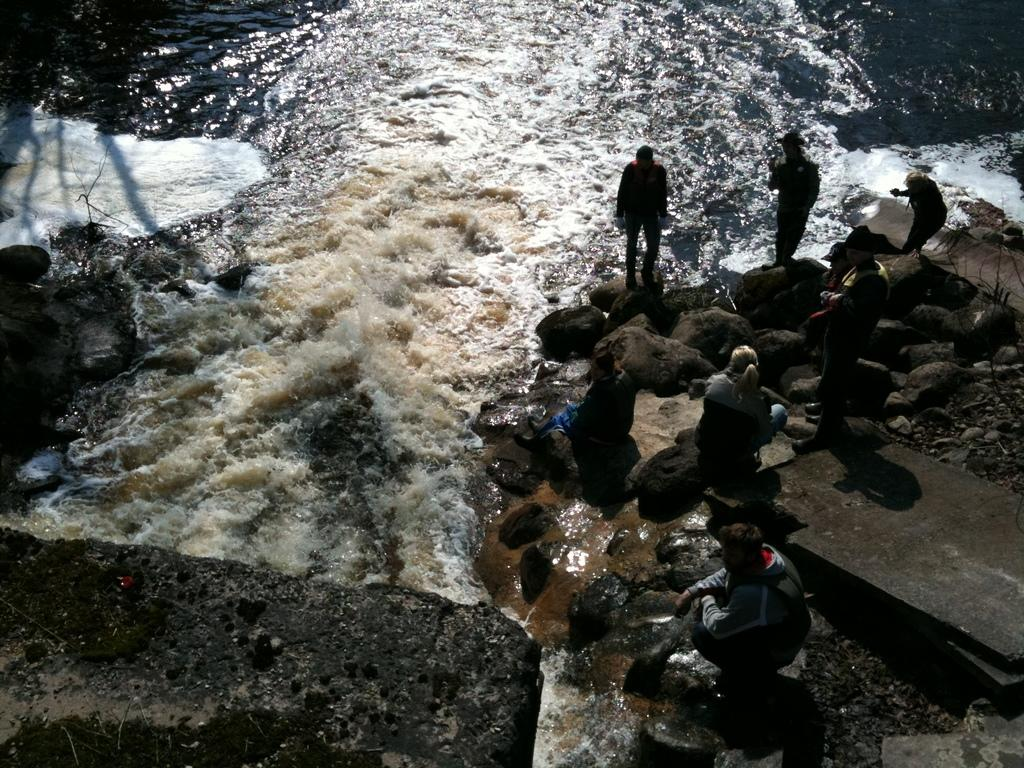How many people are in the group visible in the image? There is a group of people in the image, but the exact number cannot be determined from the provided facts. What type of natural elements can be seen in the image? There are rocks and water visible in the image. Can you describe the setting of the image? The presence of rocks and water suggests that the image might be set near a body of water, such as a river or lake. What type of hands are visible in the image? There is no mention of hands in the provided facts, so we cannot determine if any are visible in the image. 